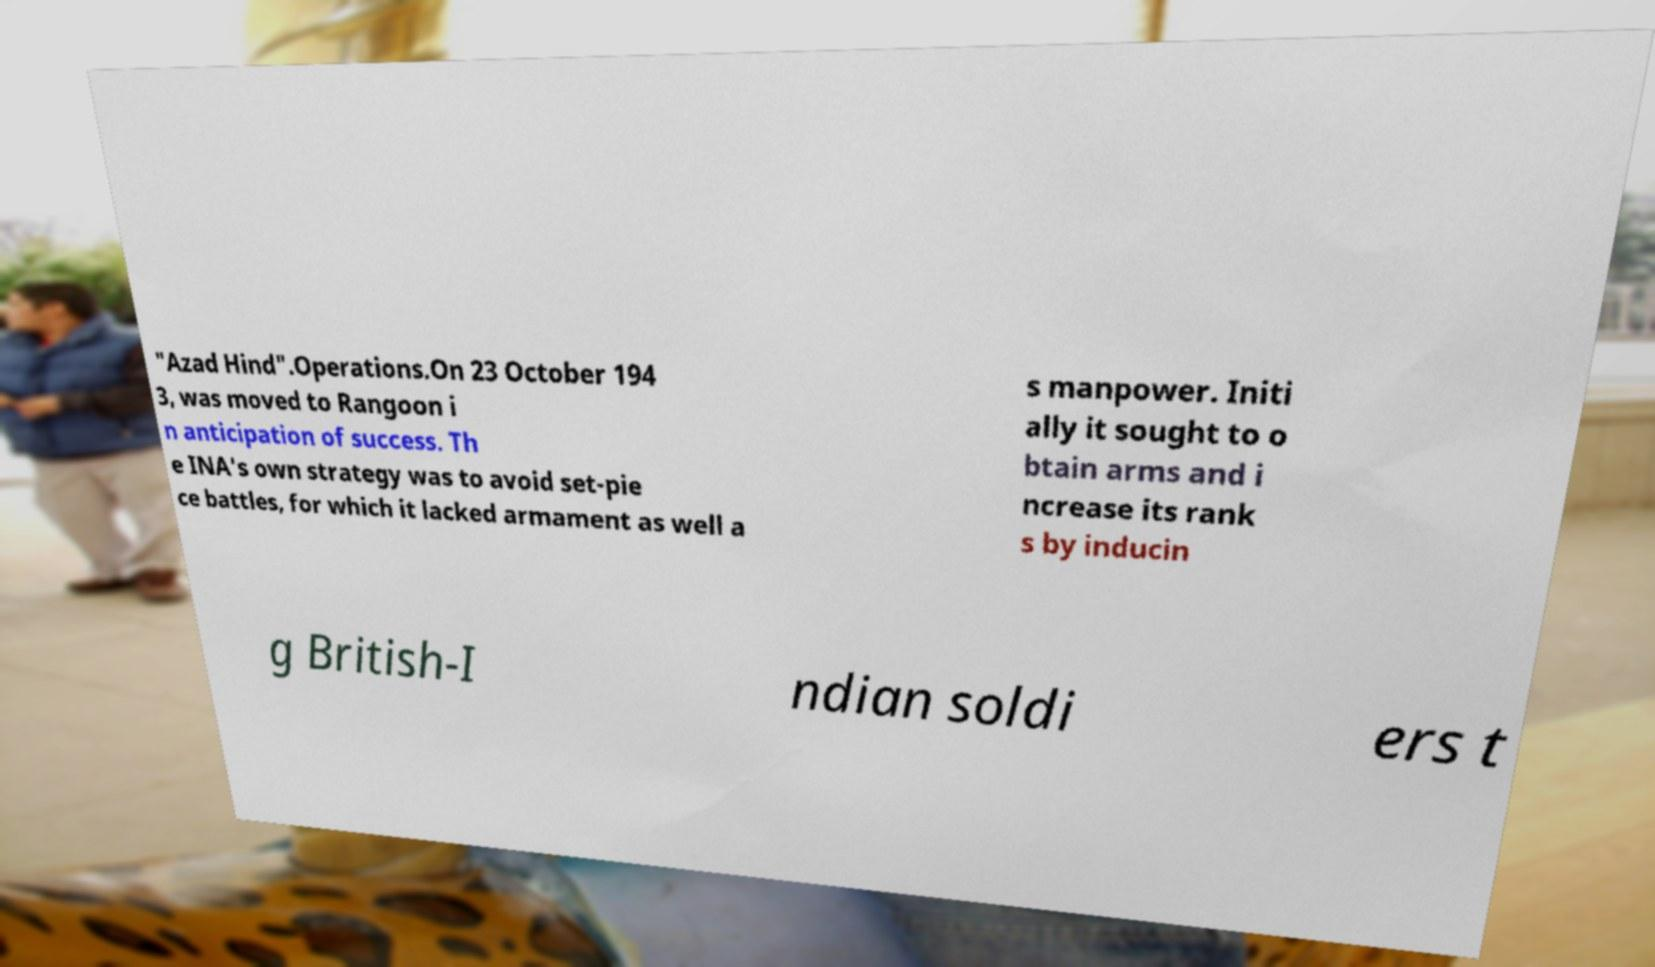Please identify and transcribe the text found in this image. "Azad Hind".Operations.On 23 October 194 3, was moved to Rangoon i n anticipation of success. Th e INA's own strategy was to avoid set-pie ce battles, for which it lacked armament as well a s manpower. Initi ally it sought to o btain arms and i ncrease its rank s by inducin g British-I ndian soldi ers t 